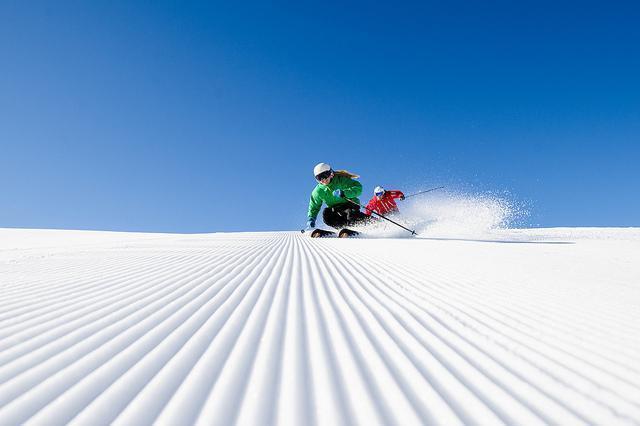The person in the lead is wearing what color jacket?
From the following set of four choices, select the accurate answer to respond to the question.
Options: Blue, yellow, green, black. Green. 